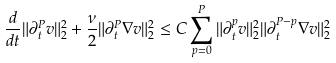Convert formula to latex. <formula><loc_0><loc_0><loc_500><loc_500>\frac { d } { d t } \| \partial ^ { P } _ { t } v \| ^ { 2 } _ { 2 } + \frac { \nu } { 2 } \| \partial ^ { P } _ { t } \nabla v \| _ { 2 } ^ { 2 } \leq C \sum _ { p = 0 } ^ { P } \| \partial _ { t } ^ { p } v \| _ { 2 } ^ { 2 } \| \partial _ { t } ^ { P - p } \nabla v \| _ { 2 } ^ { 2 }</formula> 